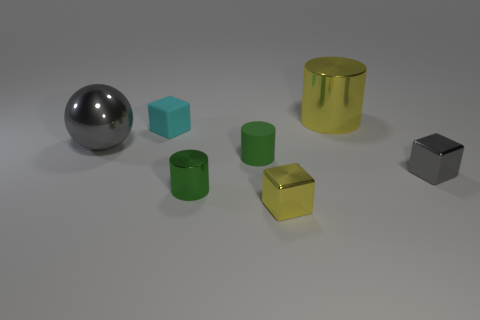Add 1 yellow metal cubes. How many objects exist? 8 Subtract all balls. How many objects are left? 6 Add 1 large green blocks. How many large green blocks exist? 1 Subtract 0 purple blocks. How many objects are left? 7 Subtract all tiny cyan cubes. Subtract all tiny matte cylinders. How many objects are left? 5 Add 6 big yellow shiny things. How many big yellow shiny things are left? 7 